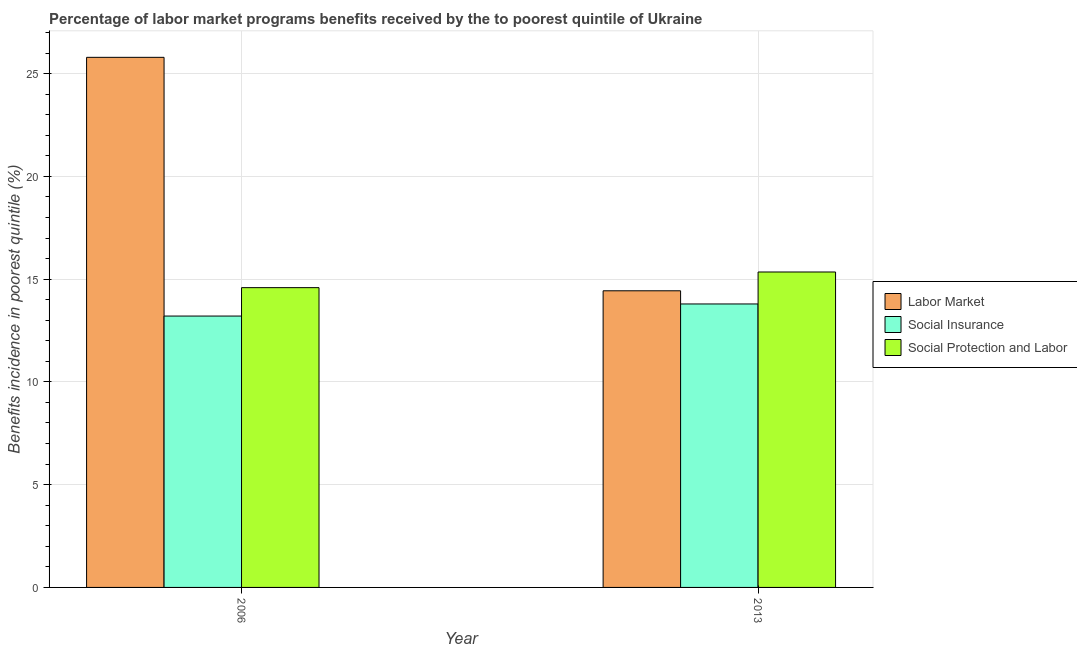How many different coloured bars are there?
Give a very brief answer. 3. Are the number of bars per tick equal to the number of legend labels?
Provide a succinct answer. Yes. How many bars are there on the 1st tick from the left?
Give a very brief answer. 3. What is the label of the 1st group of bars from the left?
Your response must be concise. 2006. In how many cases, is the number of bars for a given year not equal to the number of legend labels?
Make the answer very short. 0. What is the percentage of benefits received due to labor market programs in 2013?
Make the answer very short. 14.43. Across all years, what is the maximum percentage of benefits received due to social protection programs?
Offer a terse response. 15.35. Across all years, what is the minimum percentage of benefits received due to social protection programs?
Provide a short and direct response. 14.59. What is the total percentage of benefits received due to labor market programs in the graph?
Provide a succinct answer. 40.22. What is the difference between the percentage of benefits received due to social insurance programs in 2006 and that in 2013?
Your answer should be compact. -0.59. What is the difference between the percentage of benefits received due to social insurance programs in 2013 and the percentage of benefits received due to labor market programs in 2006?
Make the answer very short. 0.59. What is the average percentage of benefits received due to social protection programs per year?
Give a very brief answer. 14.97. In the year 2006, what is the difference between the percentage of benefits received due to social insurance programs and percentage of benefits received due to labor market programs?
Your answer should be compact. 0. What is the ratio of the percentage of benefits received due to social protection programs in 2006 to that in 2013?
Your answer should be compact. 0.95. Is the percentage of benefits received due to social protection programs in 2006 less than that in 2013?
Ensure brevity in your answer.  Yes. In how many years, is the percentage of benefits received due to social insurance programs greater than the average percentage of benefits received due to social insurance programs taken over all years?
Offer a very short reply. 1. What does the 2nd bar from the left in 2006 represents?
Make the answer very short. Social Insurance. What does the 3rd bar from the right in 2006 represents?
Your answer should be very brief. Labor Market. Are all the bars in the graph horizontal?
Make the answer very short. No. How many years are there in the graph?
Your answer should be compact. 2. What is the difference between two consecutive major ticks on the Y-axis?
Offer a terse response. 5. Does the graph contain any zero values?
Your response must be concise. No. Where does the legend appear in the graph?
Your response must be concise. Center right. What is the title of the graph?
Your answer should be very brief. Percentage of labor market programs benefits received by the to poorest quintile of Ukraine. Does "Neonatal" appear as one of the legend labels in the graph?
Ensure brevity in your answer.  No. What is the label or title of the Y-axis?
Provide a short and direct response. Benefits incidence in poorest quintile (%). What is the Benefits incidence in poorest quintile (%) of Labor Market in 2006?
Offer a very short reply. 25.79. What is the Benefits incidence in poorest quintile (%) of Social Insurance in 2006?
Provide a short and direct response. 13.2. What is the Benefits incidence in poorest quintile (%) in Social Protection and Labor in 2006?
Make the answer very short. 14.59. What is the Benefits incidence in poorest quintile (%) of Labor Market in 2013?
Your answer should be very brief. 14.43. What is the Benefits incidence in poorest quintile (%) of Social Insurance in 2013?
Provide a succinct answer. 13.79. What is the Benefits incidence in poorest quintile (%) in Social Protection and Labor in 2013?
Your response must be concise. 15.35. Across all years, what is the maximum Benefits incidence in poorest quintile (%) of Labor Market?
Offer a very short reply. 25.79. Across all years, what is the maximum Benefits incidence in poorest quintile (%) of Social Insurance?
Your response must be concise. 13.79. Across all years, what is the maximum Benefits incidence in poorest quintile (%) in Social Protection and Labor?
Offer a very short reply. 15.35. Across all years, what is the minimum Benefits incidence in poorest quintile (%) of Labor Market?
Make the answer very short. 14.43. Across all years, what is the minimum Benefits incidence in poorest quintile (%) in Social Insurance?
Provide a succinct answer. 13.2. Across all years, what is the minimum Benefits incidence in poorest quintile (%) in Social Protection and Labor?
Provide a succinct answer. 14.59. What is the total Benefits incidence in poorest quintile (%) in Labor Market in the graph?
Give a very brief answer. 40.22. What is the total Benefits incidence in poorest quintile (%) in Social Insurance in the graph?
Offer a terse response. 26.99. What is the total Benefits incidence in poorest quintile (%) of Social Protection and Labor in the graph?
Your answer should be very brief. 29.93. What is the difference between the Benefits incidence in poorest quintile (%) of Labor Market in 2006 and that in 2013?
Offer a terse response. 11.36. What is the difference between the Benefits incidence in poorest quintile (%) of Social Insurance in 2006 and that in 2013?
Your answer should be very brief. -0.59. What is the difference between the Benefits incidence in poorest quintile (%) of Social Protection and Labor in 2006 and that in 2013?
Provide a short and direct response. -0.76. What is the difference between the Benefits incidence in poorest quintile (%) in Labor Market in 2006 and the Benefits incidence in poorest quintile (%) in Social Insurance in 2013?
Offer a very short reply. 12. What is the difference between the Benefits incidence in poorest quintile (%) in Labor Market in 2006 and the Benefits incidence in poorest quintile (%) in Social Protection and Labor in 2013?
Provide a succinct answer. 10.44. What is the difference between the Benefits incidence in poorest quintile (%) of Social Insurance in 2006 and the Benefits incidence in poorest quintile (%) of Social Protection and Labor in 2013?
Your answer should be compact. -2.14. What is the average Benefits incidence in poorest quintile (%) in Labor Market per year?
Give a very brief answer. 20.11. What is the average Benefits incidence in poorest quintile (%) in Social Insurance per year?
Give a very brief answer. 13.5. What is the average Benefits incidence in poorest quintile (%) of Social Protection and Labor per year?
Give a very brief answer. 14.97. In the year 2006, what is the difference between the Benefits incidence in poorest quintile (%) in Labor Market and Benefits incidence in poorest quintile (%) in Social Insurance?
Your response must be concise. 12.59. In the year 2006, what is the difference between the Benefits incidence in poorest quintile (%) in Labor Market and Benefits incidence in poorest quintile (%) in Social Protection and Labor?
Provide a succinct answer. 11.21. In the year 2006, what is the difference between the Benefits incidence in poorest quintile (%) in Social Insurance and Benefits incidence in poorest quintile (%) in Social Protection and Labor?
Provide a short and direct response. -1.38. In the year 2013, what is the difference between the Benefits incidence in poorest quintile (%) of Labor Market and Benefits incidence in poorest quintile (%) of Social Insurance?
Your answer should be very brief. 0.64. In the year 2013, what is the difference between the Benefits incidence in poorest quintile (%) of Labor Market and Benefits incidence in poorest quintile (%) of Social Protection and Labor?
Provide a short and direct response. -0.91. In the year 2013, what is the difference between the Benefits incidence in poorest quintile (%) in Social Insurance and Benefits incidence in poorest quintile (%) in Social Protection and Labor?
Your answer should be very brief. -1.56. What is the ratio of the Benefits incidence in poorest quintile (%) of Labor Market in 2006 to that in 2013?
Offer a terse response. 1.79. What is the ratio of the Benefits incidence in poorest quintile (%) in Social Insurance in 2006 to that in 2013?
Provide a succinct answer. 0.96. What is the ratio of the Benefits incidence in poorest quintile (%) of Social Protection and Labor in 2006 to that in 2013?
Ensure brevity in your answer.  0.95. What is the difference between the highest and the second highest Benefits incidence in poorest quintile (%) in Labor Market?
Give a very brief answer. 11.36. What is the difference between the highest and the second highest Benefits incidence in poorest quintile (%) of Social Insurance?
Keep it short and to the point. 0.59. What is the difference between the highest and the second highest Benefits incidence in poorest quintile (%) in Social Protection and Labor?
Your response must be concise. 0.76. What is the difference between the highest and the lowest Benefits incidence in poorest quintile (%) of Labor Market?
Your answer should be compact. 11.36. What is the difference between the highest and the lowest Benefits incidence in poorest quintile (%) in Social Insurance?
Your answer should be very brief. 0.59. What is the difference between the highest and the lowest Benefits incidence in poorest quintile (%) in Social Protection and Labor?
Your answer should be very brief. 0.76. 